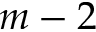<formula> <loc_0><loc_0><loc_500><loc_500>m - 2</formula> 